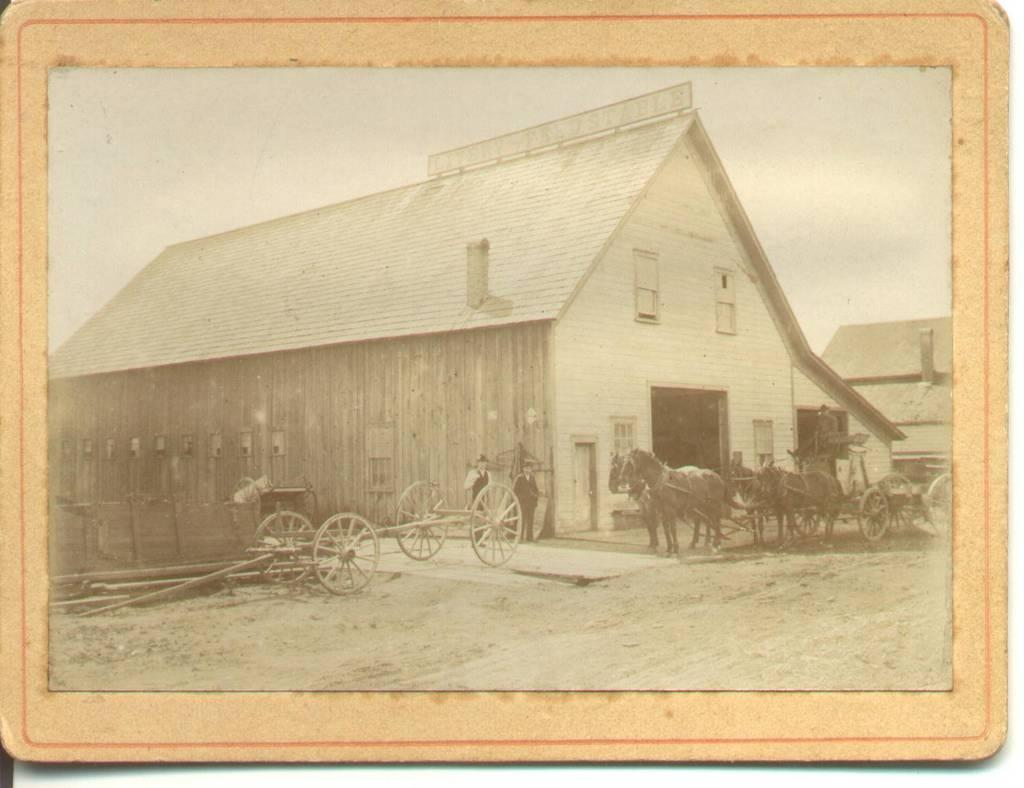What type of frame is visible in the image? There is an old photo frame in the image. What kind of structure is located near the photo frame? There is a wooden hut in the image. What can be seen in front of the wooden hut? There are empty carts and a horse cart in front of the hut. Can you see any cobwebs hanging from the photo frame in the image? There is no mention of cobwebs in the provided facts, so we cannot determine if any are present in the image. What type of musical instrument is being played in the image? There is no mention of a musical instrument in the provided facts, so we cannot determine if any are present in the image. 